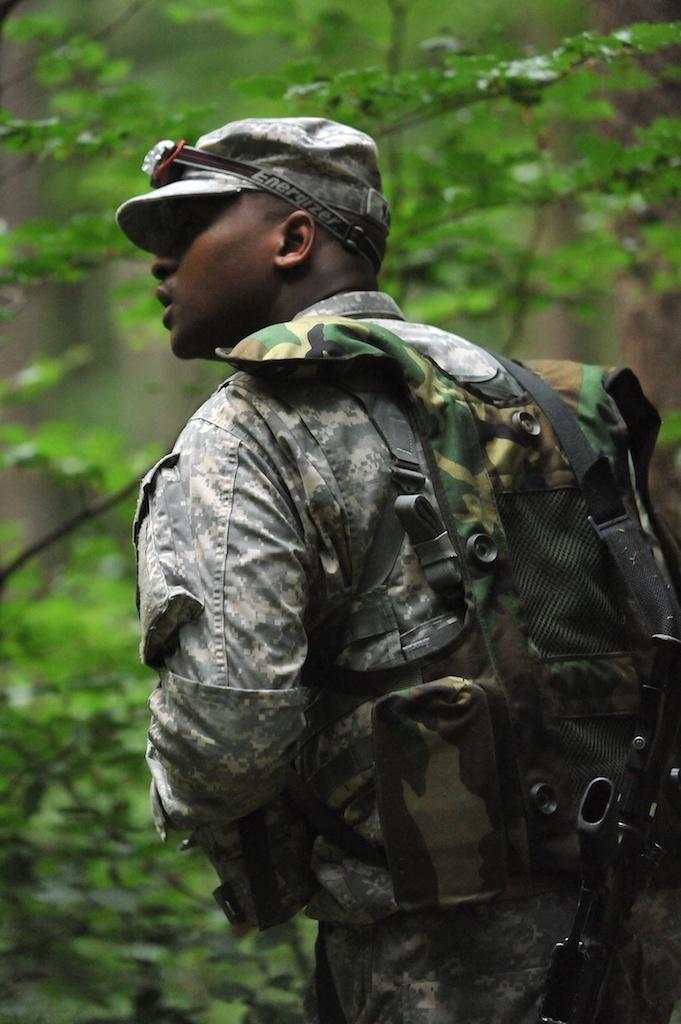In one or two sentences, can you explain what this image depicts? In the middle of the image a person is standing. In front of him there are some trees. 